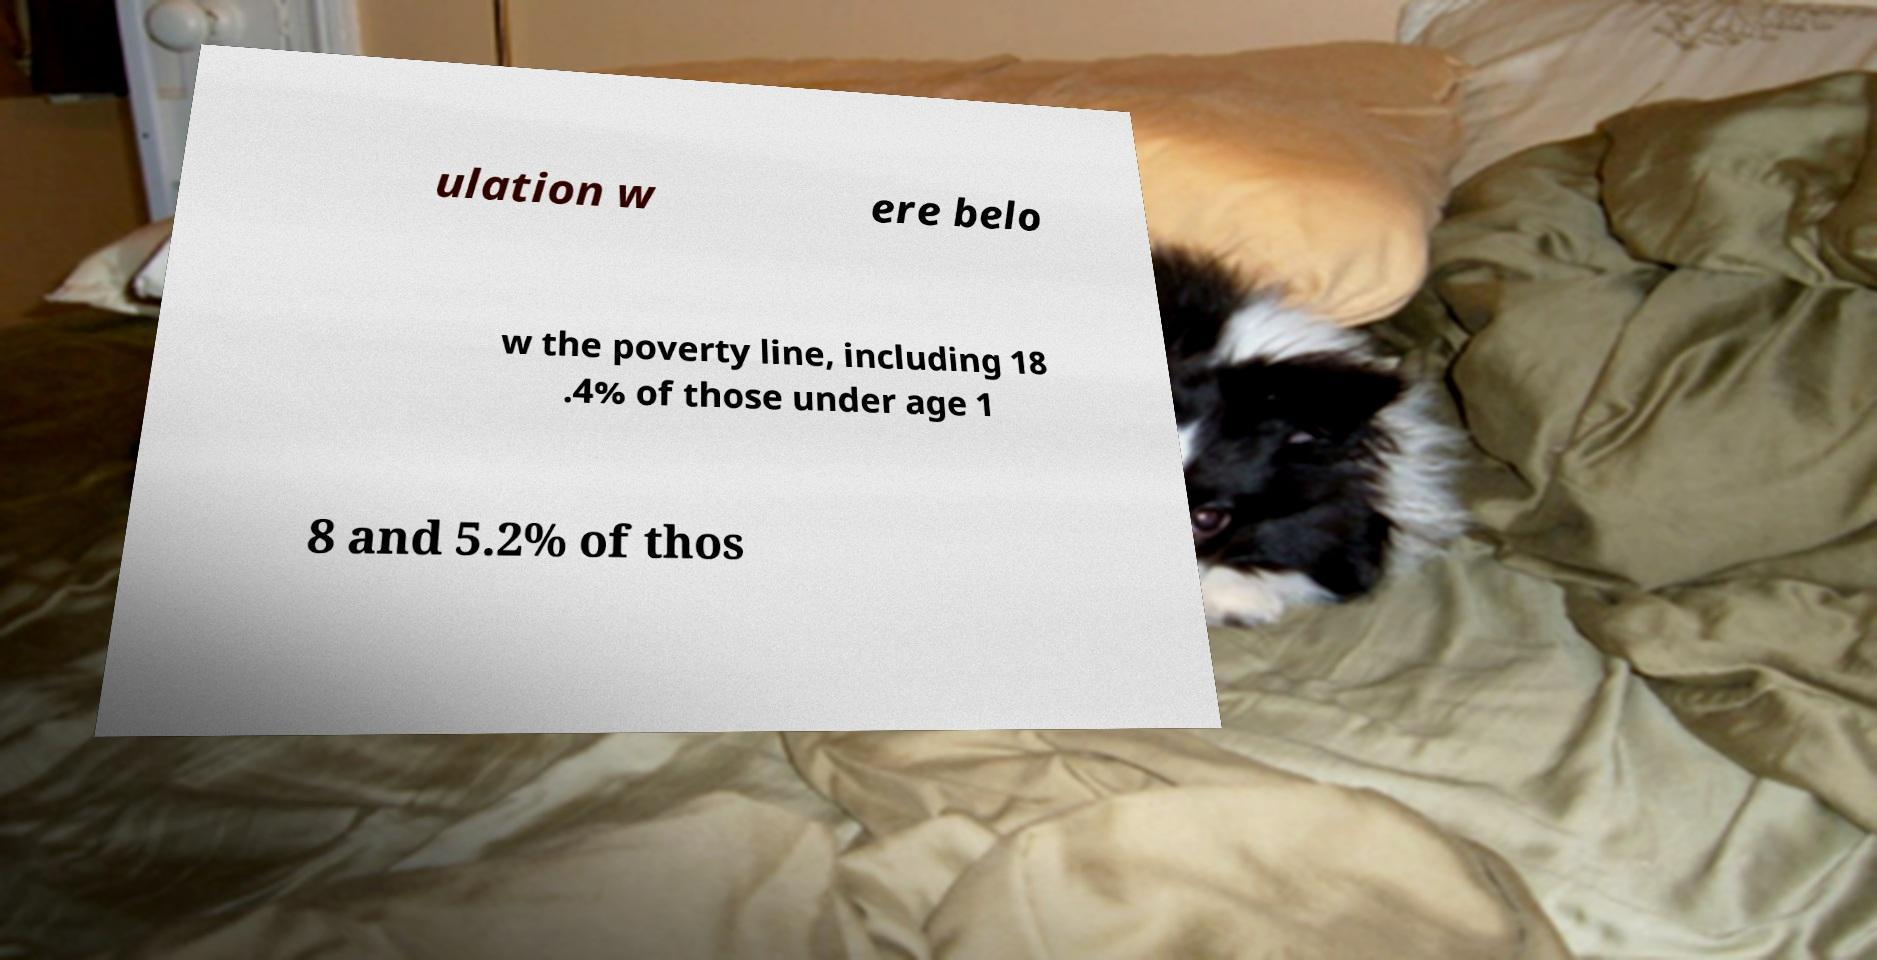Could you assist in decoding the text presented in this image and type it out clearly? ulation w ere belo w the poverty line, including 18 .4% of those under age 1 8 and 5.2% of thos 